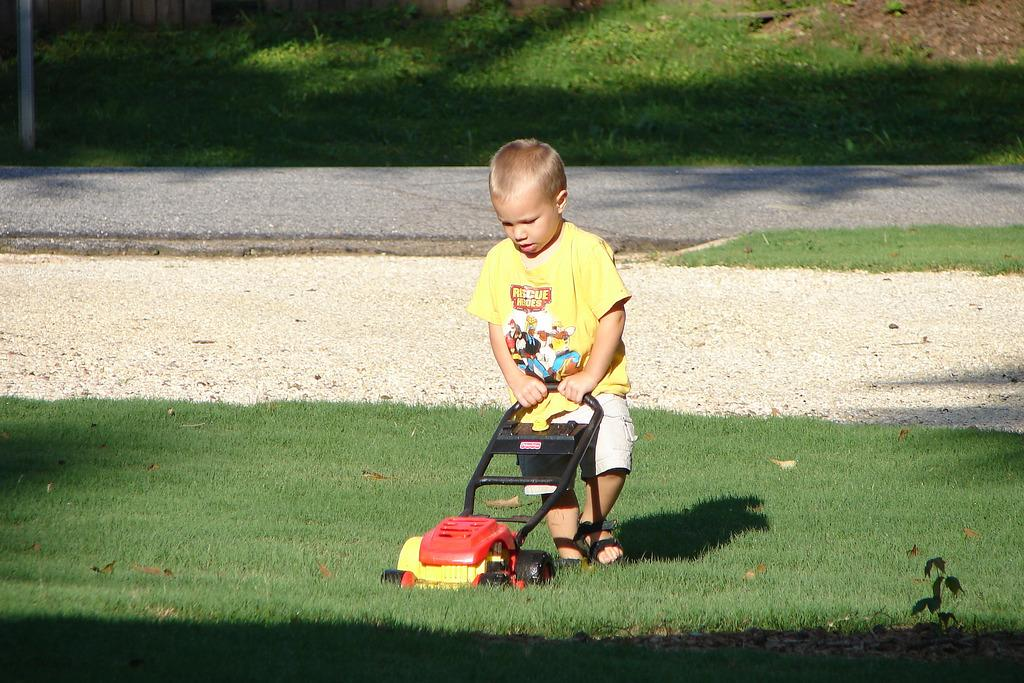What is the main subject of the image? The main subject of the image is a kid. What is the kid holding in the image? The kid is holding a grass removal tool. What is the grass removal tool being used for? The grass removal tool is being used on the grass. What type of berry can be seen growing on the grass removal tool in the image? There are no berries present on the grass removal tool in the image. 